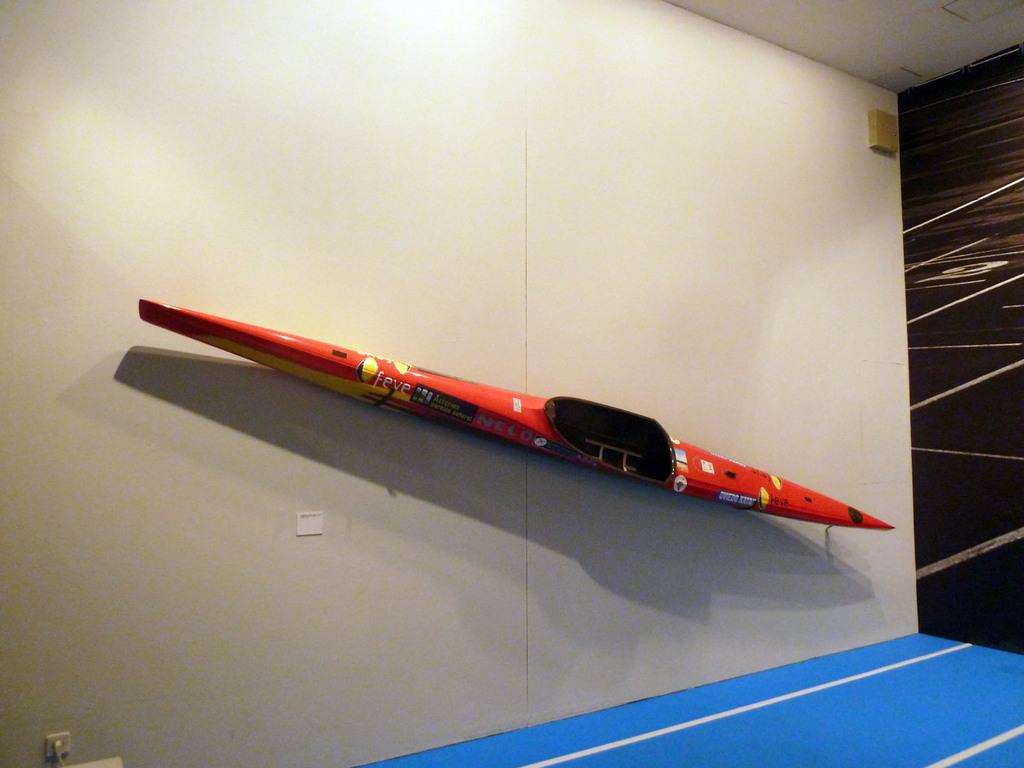What is on the wall in the image? There is an object on the wall in the image. What else can be seen in the image besides the object on the wall? There are other objects in the image. What part of the room is visible at the top of the image? The ceiling is visible in the image. Can you describe the lighting in the image? A light ray is present at the top of the image. How does the dog express its hate for plastic in the image? There is no dog or plastic present in the image, so this question cannot be answered. 